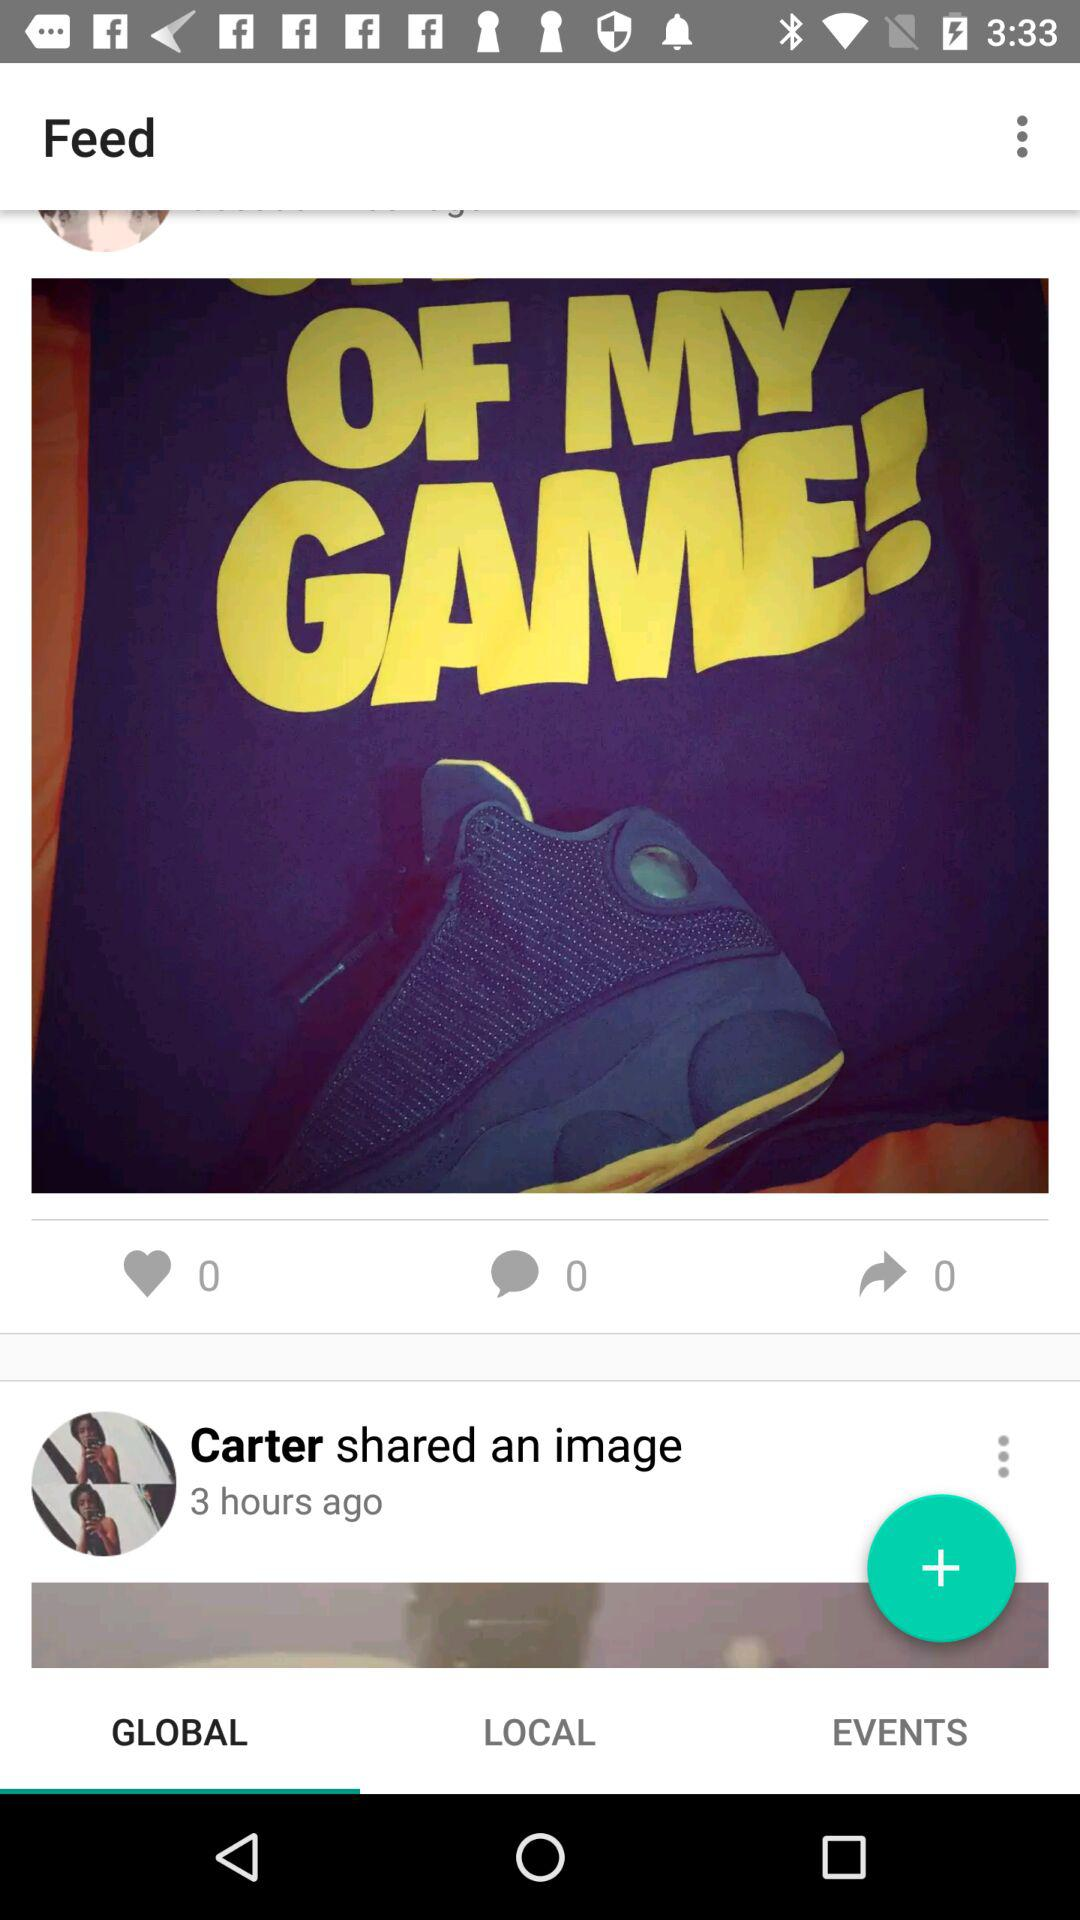How many minutes ago did Carter share the image? Carter shared the image 3 hours ago. 